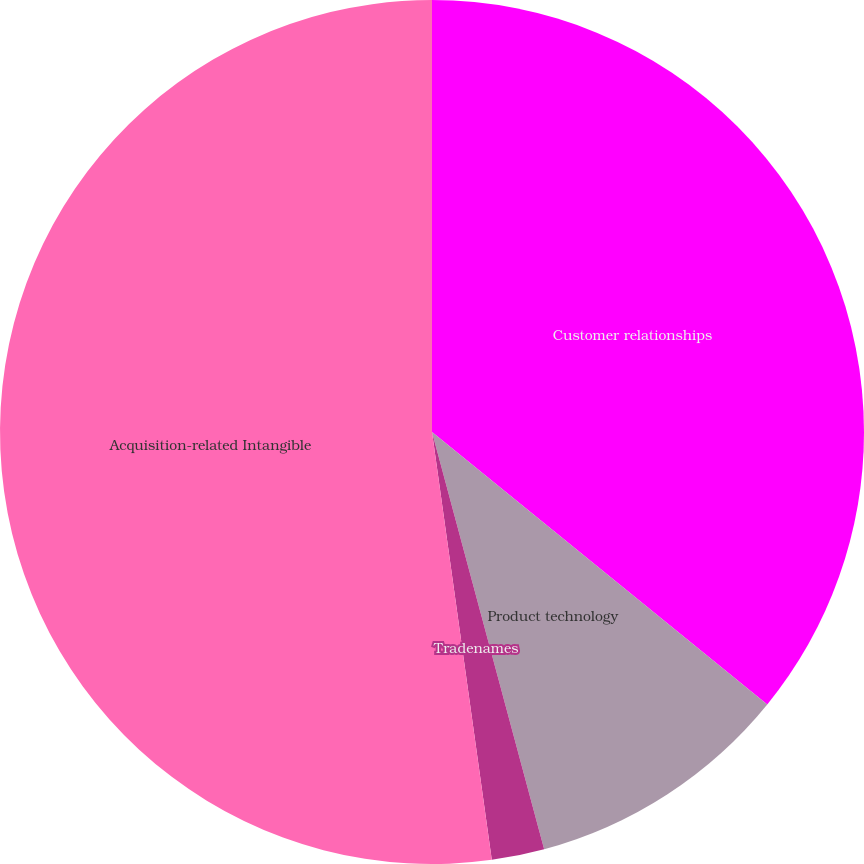<chart> <loc_0><loc_0><loc_500><loc_500><pie_chart><fcel>Customer relationships<fcel>Product technology<fcel>Tradenames<fcel>Acquisition-related Intangible<nl><fcel>35.86%<fcel>9.96%<fcel>1.97%<fcel>52.21%<nl></chart> 